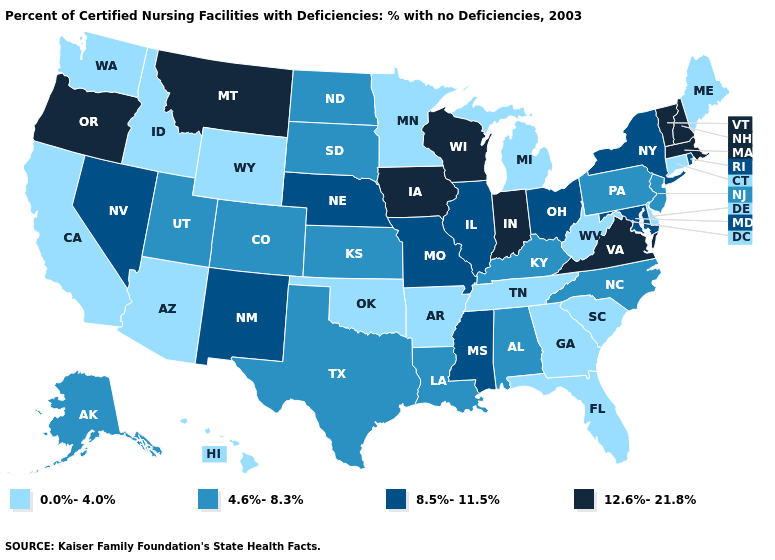Name the states that have a value in the range 8.5%-11.5%?
Be succinct. Illinois, Maryland, Mississippi, Missouri, Nebraska, Nevada, New Mexico, New York, Ohio, Rhode Island. What is the highest value in states that border Maine?
Concise answer only. 12.6%-21.8%. Which states have the highest value in the USA?
Short answer required. Indiana, Iowa, Massachusetts, Montana, New Hampshire, Oregon, Vermont, Virginia, Wisconsin. Among the states that border Michigan , does Ohio have the highest value?
Be succinct. No. What is the highest value in the USA?
Answer briefly. 12.6%-21.8%. What is the highest value in the USA?
Answer briefly. 12.6%-21.8%. What is the value of Texas?
Give a very brief answer. 4.6%-8.3%. Among the states that border Louisiana , which have the highest value?
Be succinct. Mississippi. Does West Virginia have the lowest value in the USA?
Answer briefly. Yes. Does Mississippi have a higher value than New Mexico?
Keep it brief. No. What is the highest value in states that border Pennsylvania?
Be succinct. 8.5%-11.5%. Name the states that have a value in the range 0.0%-4.0%?
Be succinct. Arizona, Arkansas, California, Connecticut, Delaware, Florida, Georgia, Hawaii, Idaho, Maine, Michigan, Minnesota, Oklahoma, South Carolina, Tennessee, Washington, West Virginia, Wyoming. Does Virginia have the lowest value in the USA?
Write a very short answer. No. Among the states that border New Mexico , does Utah have the lowest value?
Keep it brief. No. Does California have the lowest value in the USA?
Write a very short answer. Yes. 